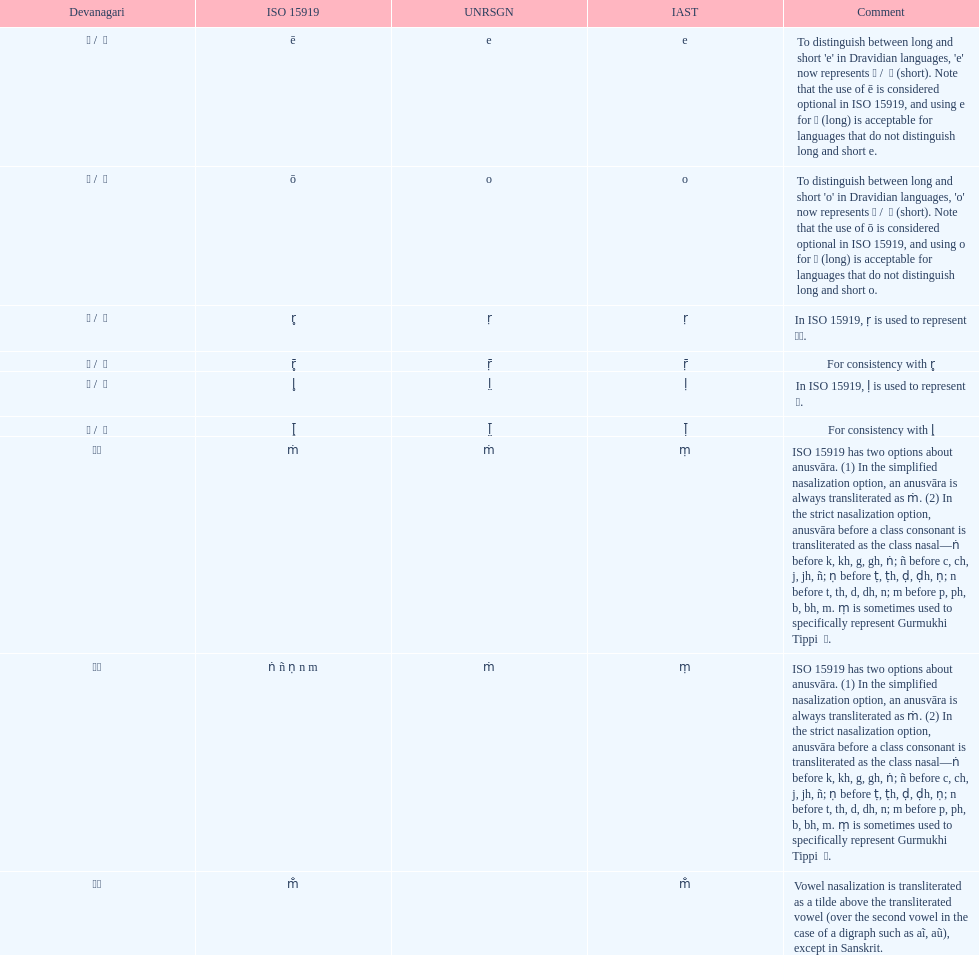In iso 15919, what is mentioned before the use of &#7735; to represent &#2355; under the comments section? For consistency with r̥. 